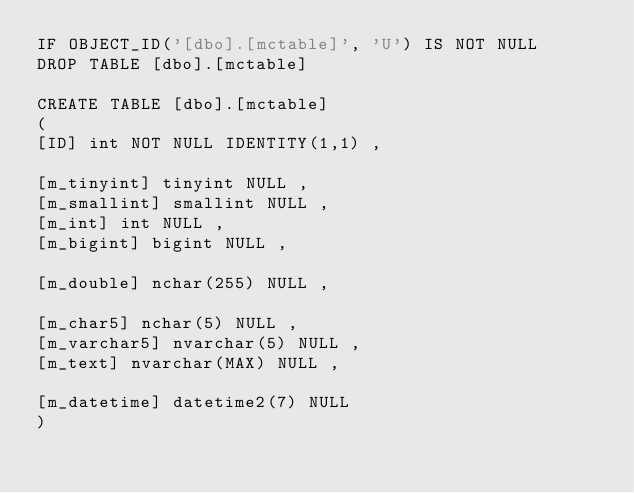<code> <loc_0><loc_0><loc_500><loc_500><_SQL_>IF OBJECT_ID('[dbo].[mctable]', 'U') IS NOT NULL 
DROP TABLE [dbo].[mctable]

CREATE TABLE [dbo].[mctable] 
(
[ID] int NOT NULL IDENTITY(1,1) ,

[m_tinyint] tinyint NULL ,
[m_smallint] smallint NULL ,
[m_int] int NULL ,
[m_bigint] bigint NULL ,

[m_double] nchar(255) NULL ,

[m_char5] nchar(5) NULL ,
[m_varchar5] nvarchar(5) NULL ,
[m_text] nvarchar(MAX) NULL ,

[m_datetime] datetime2(7) NULL 
)</code> 